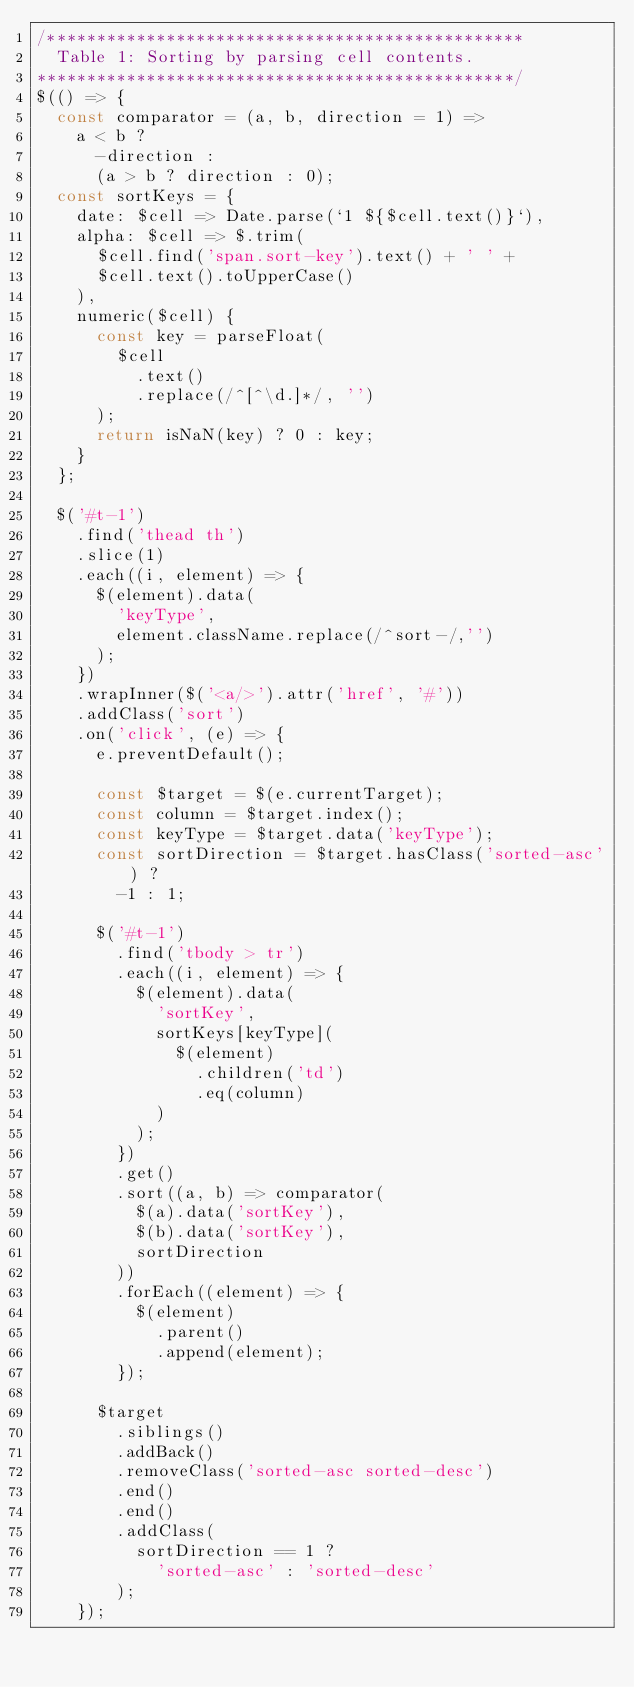Convert code to text. <code><loc_0><loc_0><loc_500><loc_500><_JavaScript_>/************************************************
  Table 1: Sorting by parsing cell contents.
************************************************/
$(() => {
  const comparator = (a, b, direction = 1) =>
    a < b ?
      -direction :
      (a > b ? direction : 0);
  const sortKeys = {
    date: $cell => Date.parse(`1 ${$cell.text()}`),
    alpha: $cell => $.trim(
      $cell.find('span.sort-key').text() + ' ' +
      $cell.text().toUpperCase()
    ),
    numeric($cell) {
      const key = parseFloat(
        $cell
          .text()
          .replace(/^[^\d.]*/, '')
      );
      return isNaN(key) ? 0 : key;
    }
  };

  $('#t-1')
    .find('thead th')
    .slice(1)
    .each((i, element) => {
      $(element).data(
        'keyType',
        element.className.replace(/^sort-/,'')
      );
    })
    .wrapInner($('<a/>').attr('href', '#'))
    .addClass('sort')
    .on('click', (e) => {
      e.preventDefault();

      const $target = $(e.currentTarget);
      const column = $target.index();
      const keyType = $target.data('keyType');
      const sortDirection = $target.hasClass('sorted-asc') ?
        -1 : 1;

      $('#t-1')
        .find('tbody > tr')
        .each((i, element) => {
          $(element).data(
            'sortKey',
            sortKeys[keyType](
              $(element)
                .children('td')
                .eq(column)
            )
          );
        })
        .get()
        .sort((a, b) => comparator(
          $(a).data('sortKey'),
          $(b).data('sortKey'),
          sortDirection
        ))
        .forEach((element) => {
          $(element)
            .parent()
            .append(element);
        });

      $target
        .siblings()
        .addBack()
        .removeClass('sorted-asc sorted-desc')
        .end()
        .end()
        .addClass(
          sortDirection == 1 ?
            'sorted-asc' : 'sorted-desc'
        );
    });</code> 